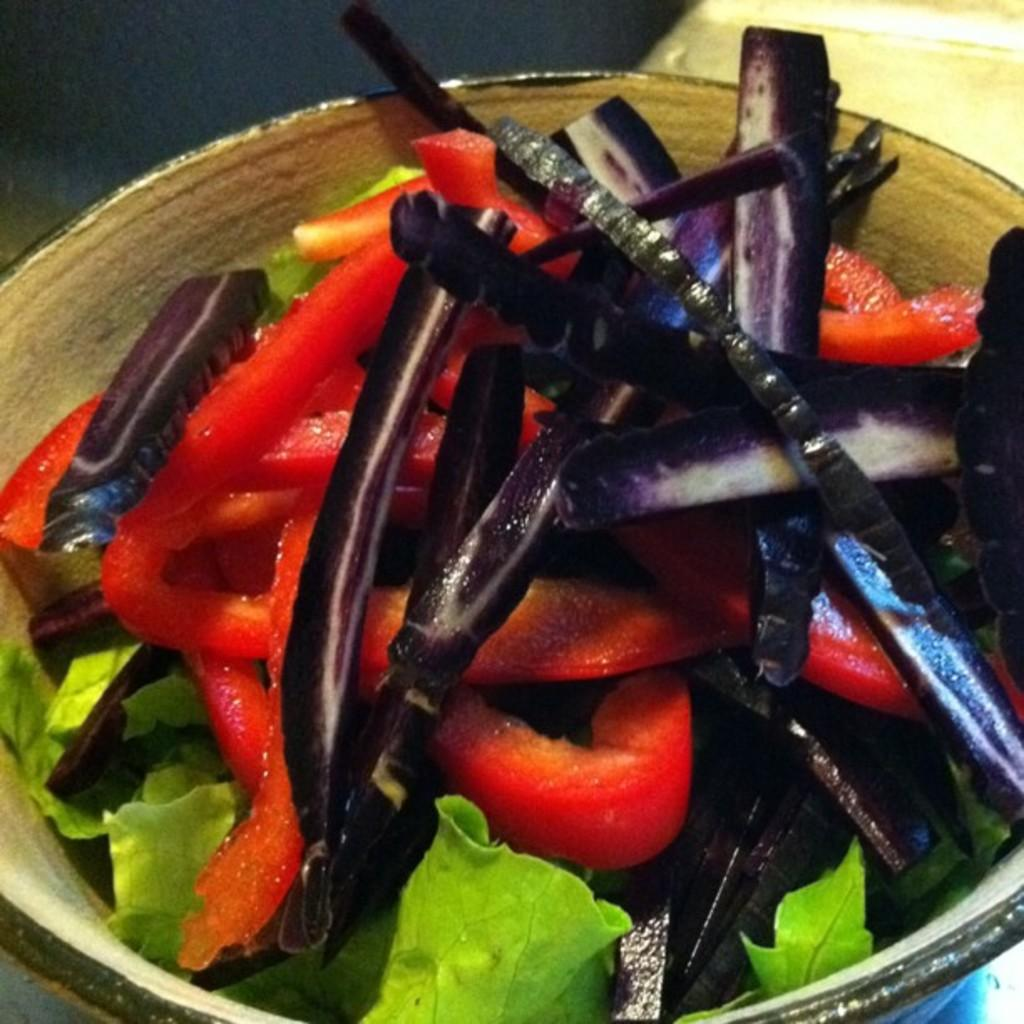What type of food can be seen in the image? There are vegetables in the image. How are the vegetables arranged or presented in the image? The vegetables are placed in a bowl. What type of coal is being used to heat the vegetables in the image? There is no coal or heating process depicted in the image; it simply shows vegetables placed in a bowl. 